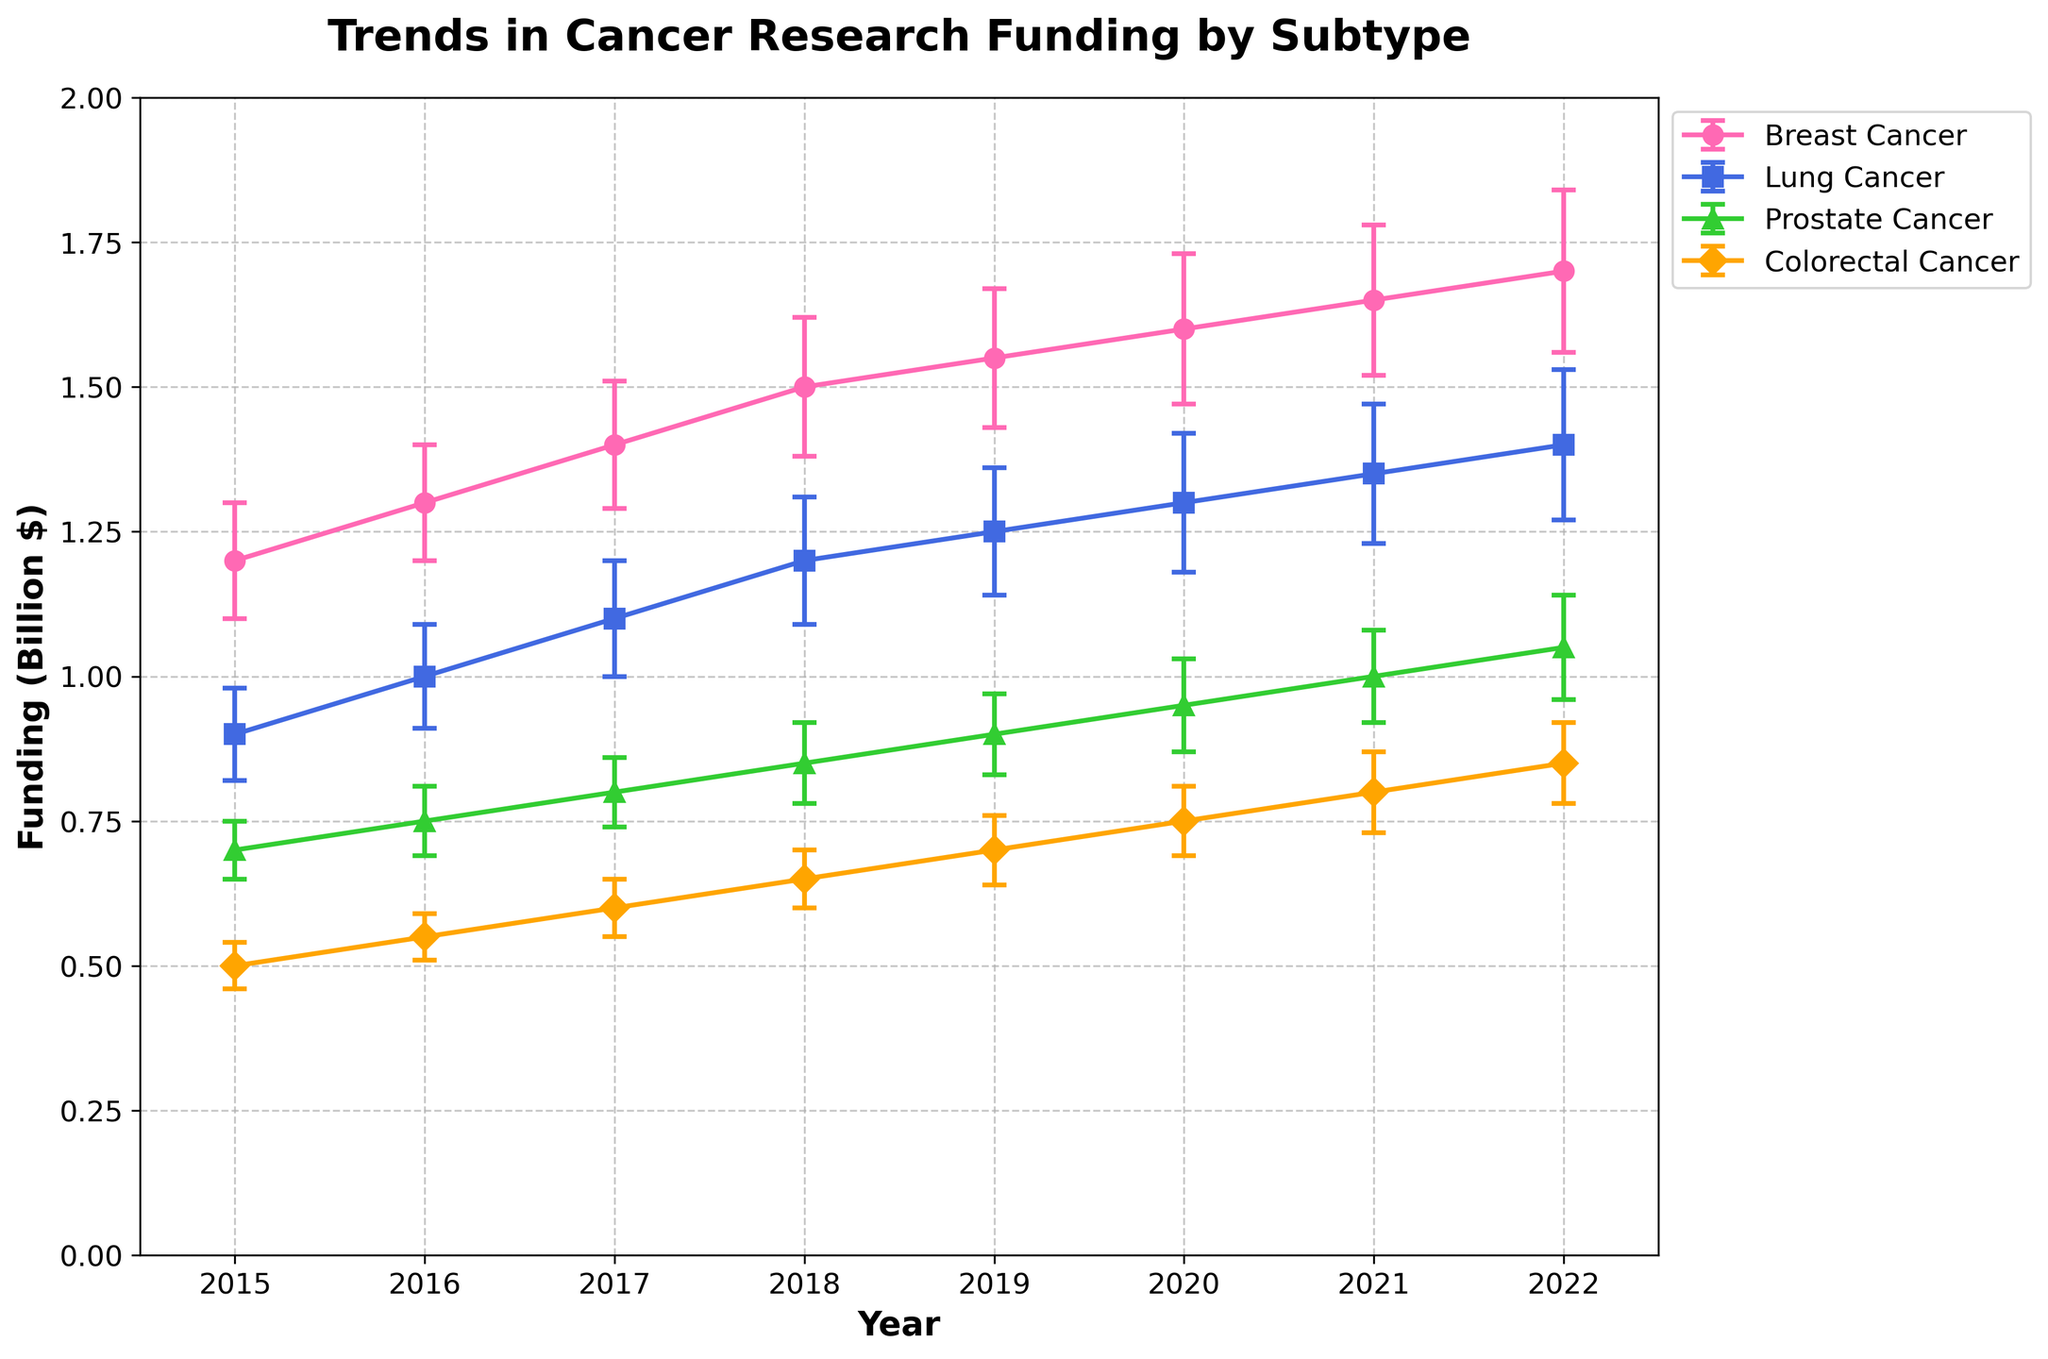How many cancer subtypes are shown in the plot? The figure legend shows different cancer subtypes being compared in the plot. Counting the number of distinct labels in the legend will give the answer.
Answer: 4 What is the title of the plot? The title is usually found at the top center of the plot in a larger font size compared to other text elements.
Answer: Trends in Cancer Research Funding by Subtype Which cancer subtype received the most annual funding in 2022? To find which subtype received the most funding in 2022, look for the highest data point in 2022 on the y-axis and identify the corresponding cancer subtype from the legend or line markers.
Answer: Breast Cancer What was the approximate funding amount for Lung Cancer research in 2019? Locate the 2019 data point for Lung Cancer on the x-axis. Then, trace vertically to the y-axis to find the funding amount.
Answer: 1.25 Billion $ Between which years did Breast Cancer research funding increase the most? Compare the funding amounts for Breast Cancer over each year. Calculate the differences between consecutive years to determine the largest increase.
Answer: 2015 to 2016 Which cancer subtype shows the smallest error bars in most years? Compare the lengths of the error bars for each year for all subtypes and identify the subtype with the shortest error bars consistently.
Answer: Colorectal Cancer What does the y-axis represent? The y-axis label gives us information about what is being measured. It is usually located vertically along the left side of the plot.
Answer: Funding (Billion $) Did Prostate Cancer research funding exceed 0.8 Billion $ before 2020? Examine the data points for Prostate Cancer on the y-axis for all years before 2020 to check if any of them are above 0.8 Billion $.
Answer: No Which year showed the highest increase in funding for Lung Cancer? To find the year with the highest increase, compare the funding amounts of Lung Cancer for each year and determine the largest year-to-year increment.
Answer: 2015 to 2016 Between 2017 and 2022, which cancer subtype's funding increased the least? Calculate the difference in funding for each subtype between 2017 and 2022. The subtype with the smallest increase will be the answer.
Answer: Prostate Cancer 